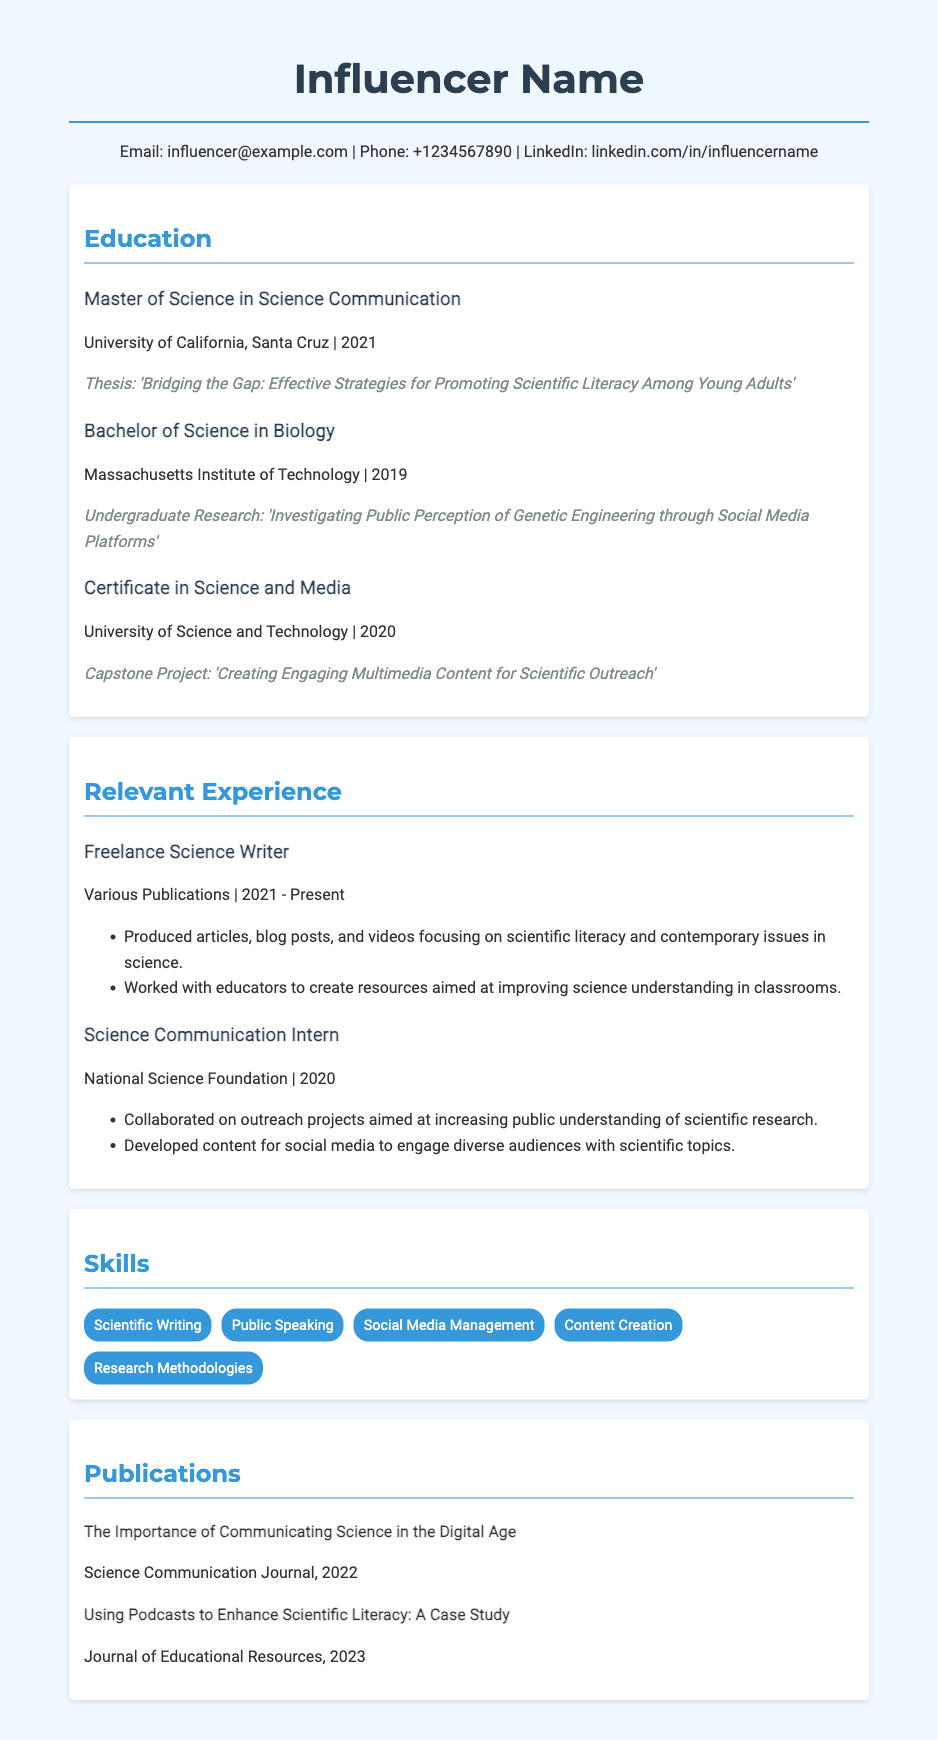What degree did the influencer obtain in 2021? The influencer obtained a Master of Science in Science Communication in 2021.
Answer: Master of Science in Science Communication What is the title of the influencer's master's thesis? The title of the influencer's master's thesis is 'Bridging the Gap: Effective Strategies for Promoting Scientific Literacy Among Young Adults'.
Answer: Bridging the Gap: Effective Strategies for Promoting Scientific Literacy Among Young Adults Which university awarded the influencer their bachelor's degree? The influencer's bachelor's degree was awarded by the Massachusetts Institute of Technology.
Answer: Massachusetts Institute of Technology What notable undergraduate research was conducted by the influencer? The notable undergraduate research conducted by the influencer was 'Investigating Public Perception of Genetic Engineering through Social Media Platforms'.
Answer: Investigating Public Perception of Genetic Engineering through Social Media Platforms In which year did the influencer complete their Certificate in Science and Media? The influencer completed their Certificate in Science and Media in 2020.
Answer: 2020 How many years of experience does the influencer have as a Freelance Science Writer? The influencer has done freelance science writing from 2021 to the present, which accounts for 2 years.
Answer: 2 years What type of projects did the influencer work on as a Science Communication Intern? As a Science Communication Intern, the influencer worked on outreach projects aimed at increasing public understanding of scientific research.
Answer: Outreach projects What skills are listed in the influencer's CV? The skills listed include Scientific Writing, Public Speaking, Social Media Management, Content Creation, and Research Methodologies.
Answer: Scientific Writing, Public Speaking, Social Media Management, Content Creation, Research Methodologies What is a publication authored by the influencer? One of the publications authored by the influencer is 'The Importance of Communicating Science in the Digital Age'.
Answer: The Importance of Communicating Science in the Digital Age 